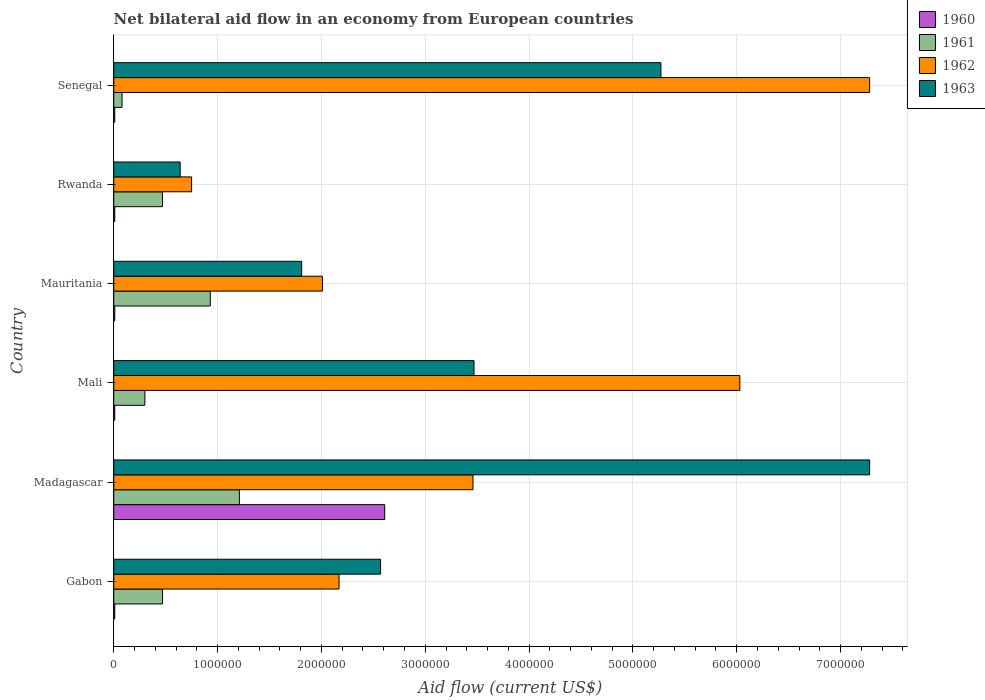What is the label of the 2nd group of bars from the top?
Your answer should be very brief. Rwanda. In how many cases, is the number of bars for a given country not equal to the number of legend labels?
Ensure brevity in your answer.  0. What is the net bilateral aid flow in 1961 in Mauritania?
Your answer should be compact. 9.30e+05. Across all countries, what is the maximum net bilateral aid flow in 1962?
Ensure brevity in your answer.  7.28e+06. In which country was the net bilateral aid flow in 1962 maximum?
Ensure brevity in your answer.  Senegal. In which country was the net bilateral aid flow in 1963 minimum?
Your answer should be very brief. Rwanda. What is the total net bilateral aid flow in 1960 in the graph?
Keep it short and to the point. 2.66e+06. What is the difference between the net bilateral aid flow in 1963 in Gabon and that in Senegal?
Ensure brevity in your answer.  -2.70e+06. What is the difference between the net bilateral aid flow in 1963 in Rwanda and the net bilateral aid flow in 1960 in Madagascar?
Keep it short and to the point. -1.97e+06. What is the average net bilateral aid flow in 1963 per country?
Give a very brief answer. 3.51e+06. What is the ratio of the net bilateral aid flow in 1960 in Mauritania to that in Rwanda?
Offer a terse response. 1. Is the net bilateral aid flow in 1960 in Mali less than that in Senegal?
Your response must be concise. No. What is the difference between the highest and the lowest net bilateral aid flow in 1962?
Give a very brief answer. 6.53e+06. In how many countries, is the net bilateral aid flow in 1961 greater than the average net bilateral aid flow in 1961 taken over all countries?
Offer a terse response. 2. What does the 4th bar from the top in Mali represents?
Offer a very short reply. 1960. Is it the case that in every country, the sum of the net bilateral aid flow in 1962 and net bilateral aid flow in 1960 is greater than the net bilateral aid flow in 1963?
Your answer should be compact. No. How many bars are there?
Provide a succinct answer. 24. What is the difference between two consecutive major ticks on the X-axis?
Your response must be concise. 1.00e+06. Are the values on the major ticks of X-axis written in scientific E-notation?
Make the answer very short. No. How are the legend labels stacked?
Your response must be concise. Vertical. What is the title of the graph?
Provide a short and direct response. Net bilateral aid flow in an economy from European countries. Does "1998" appear as one of the legend labels in the graph?
Your answer should be very brief. No. What is the label or title of the X-axis?
Make the answer very short. Aid flow (current US$). What is the label or title of the Y-axis?
Offer a terse response. Country. What is the Aid flow (current US$) in 1961 in Gabon?
Provide a succinct answer. 4.70e+05. What is the Aid flow (current US$) of 1962 in Gabon?
Keep it short and to the point. 2.17e+06. What is the Aid flow (current US$) in 1963 in Gabon?
Your answer should be very brief. 2.57e+06. What is the Aid flow (current US$) in 1960 in Madagascar?
Your answer should be very brief. 2.61e+06. What is the Aid flow (current US$) in 1961 in Madagascar?
Your answer should be compact. 1.21e+06. What is the Aid flow (current US$) in 1962 in Madagascar?
Your answer should be very brief. 3.46e+06. What is the Aid flow (current US$) in 1963 in Madagascar?
Provide a short and direct response. 7.28e+06. What is the Aid flow (current US$) in 1962 in Mali?
Ensure brevity in your answer.  6.03e+06. What is the Aid flow (current US$) in 1963 in Mali?
Offer a very short reply. 3.47e+06. What is the Aid flow (current US$) in 1961 in Mauritania?
Give a very brief answer. 9.30e+05. What is the Aid flow (current US$) of 1962 in Mauritania?
Make the answer very short. 2.01e+06. What is the Aid flow (current US$) in 1963 in Mauritania?
Give a very brief answer. 1.81e+06. What is the Aid flow (current US$) of 1961 in Rwanda?
Your answer should be compact. 4.70e+05. What is the Aid flow (current US$) in 1962 in Rwanda?
Your answer should be compact. 7.50e+05. What is the Aid flow (current US$) of 1963 in Rwanda?
Make the answer very short. 6.40e+05. What is the Aid flow (current US$) of 1961 in Senegal?
Offer a terse response. 8.00e+04. What is the Aid flow (current US$) in 1962 in Senegal?
Keep it short and to the point. 7.28e+06. What is the Aid flow (current US$) of 1963 in Senegal?
Make the answer very short. 5.27e+06. Across all countries, what is the maximum Aid flow (current US$) in 1960?
Your answer should be very brief. 2.61e+06. Across all countries, what is the maximum Aid flow (current US$) of 1961?
Give a very brief answer. 1.21e+06. Across all countries, what is the maximum Aid flow (current US$) in 1962?
Your response must be concise. 7.28e+06. Across all countries, what is the maximum Aid flow (current US$) of 1963?
Provide a succinct answer. 7.28e+06. Across all countries, what is the minimum Aid flow (current US$) in 1960?
Keep it short and to the point. 10000. Across all countries, what is the minimum Aid flow (current US$) in 1962?
Offer a terse response. 7.50e+05. Across all countries, what is the minimum Aid flow (current US$) of 1963?
Provide a succinct answer. 6.40e+05. What is the total Aid flow (current US$) of 1960 in the graph?
Provide a short and direct response. 2.66e+06. What is the total Aid flow (current US$) in 1961 in the graph?
Provide a short and direct response. 3.46e+06. What is the total Aid flow (current US$) in 1962 in the graph?
Keep it short and to the point. 2.17e+07. What is the total Aid flow (current US$) of 1963 in the graph?
Your answer should be compact. 2.10e+07. What is the difference between the Aid flow (current US$) in 1960 in Gabon and that in Madagascar?
Ensure brevity in your answer.  -2.60e+06. What is the difference between the Aid flow (current US$) in 1961 in Gabon and that in Madagascar?
Give a very brief answer. -7.40e+05. What is the difference between the Aid flow (current US$) in 1962 in Gabon and that in Madagascar?
Keep it short and to the point. -1.29e+06. What is the difference between the Aid flow (current US$) in 1963 in Gabon and that in Madagascar?
Provide a succinct answer. -4.71e+06. What is the difference between the Aid flow (current US$) of 1961 in Gabon and that in Mali?
Provide a short and direct response. 1.70e+05. What is the difference between the Aid flow (current US$) of 1962 in Gabon and that in Mali?
Offer a very short reply. -3.86e+06. What is the difference between the Aid flow (current US$) in 1963 in Gabon and that in Mali?
Offer a very short reply. -9.00e+05. What is the difference between the Aid flow (current US$) of 1960 in Gabon and that in Mauritania?
Your answer should be very brief. 0. What is the difference between the Aid flow (current US$) of 1961 in Gabon and that in Mauritania?
Your response must be concise. -4.60e+05. What is the difference between the Aid flow (current US$) in 1963 in Gabon and that in Mauritania?
Provide a short and direct response. 7.60e+05. What is the difference between the Aid flow (current US$) in 1960 in Gabon and that in Rwanda?
Offer a terse response. 0. What is the difference between the Aid flow (current US$) in 1962 in Gabon and that in Rwanda?
Ensure brevity in your answer.  1.42e+06. What is the difference between the Aid flow (current US$) in 1963 in Gabon and that in Rwanda?
Keep it short and to the point. 1.93e+06. What is the difference between the Aid flow (current US$) of 1960 in Gabon and that in Senegal?
Ensure brevity in your answer.  0. What is the difference between the Aid flow (current US$) of 1962 in Gabon and that in Senegal?
Keep it short and to the point. -5.11e+06. What is the difference between the Aid flow (current US$) of 1963 in Gabon and that in Senegal?
Give a very brief answer. -2.70e+06. What is the difference between the Aid flow (current US$) in 1960 in Madagascar and that in Mali?
Offer a very short reply. 2.60e+06. What is the difference between the Aid flow (current US$) in 1961 in Madagascar and that in Mali?
Provide a short and direct response. 9.10e+05. What is the difference between the Aid flow (current US$) in 1962 in Madagascar and that in Mali?
Provide a short and direct response. -2.57e+06. What is the difference between the Aid flow (current US$) of 1963 in Madagascar and that in Mali?
Your answer should be compact. 3.81e+06. What is the difference between the Aid flow (current US$) of 1960 in Madagascar and that in Mauritania?
Your response must be concise. 2.60e+06. What is the difference between the Aid flow (current US$) in 1961 in Madagascar and that in Mauritania?
Offer a terse response. 2.80e+05. What is the difference between the Aid flow (current US$) of 1962 in Madagascar and that in Mauritania?
Provide a succinct answer. 1.45e+06. What is the difference between the Aid flow (current US$) of 1963 in Madagascar and that in Mauritania?
Provide a short and direct response. 5.47e+06. What is the difference between the Aid flow (current US$) in 1960 in Madagascar and that in Rwanda?
Give a very brief answer. 2.60e+06. What is the difference between the Aid flow (current US$) in 1961 in Madagascar and that in Rwanda?
Provide a succinct answer. 7.40e+05. What is the difference between the Aid flow (current US$) in 1962 in Madagascar and that in Rwanda?
Provide a succinct answer. 2.71e+06. What is the difference between the Aid flow (current US$) in 1963 in Madagascar and that in Rwanda?
Offer a terse response. 6.64e+06. What is the difference between the Aid flow (current US$) in 1960 in Madagascar and that in Senegal?
Your response must be concise. 2.60e+06. What is the difference between the Aid flow (current US$) of 1961 in Madagascar and that in Senegal?
Offer a terse response. 1.13e+06. What is the difference between the Aid flow (current US$) in 1962 in Madagascar and that in Senegal?
Your answer should be compact. -3.82e+06. What is the difference between the Aid flow (current US$) of 1963 in Madagascar and that in Senegal?
Your response must be concise. 2.01e+06. What is the difference between the Aid flow (current US$) in 1960 in Mali and that in Mauritania?
Ensure brevity in your answer.  0. What is the difference between the Aid flow (current US$) of 1961 in Mali and that in Mauritania?
Offer a terse response. -6.30e+05. What is the difference between the Aid flow (current US$) of 1962 in Mali and that in Mauritania?
Provide a succinct answer. 4.02e+06. What is the difference between the Aid flow (current US$) in 1963 in Mali and that in Mauritania?
Provide a succinct answer. 1.66e+06. What is the difference between the Aid flow (current US$) in 1960 in Mali and that in Rwanda?
Make the answer very short. 0. What is the difference between the Aid flow (current US$) of 1962 in Mali and that in Rwanda?
Your answer should be compact. 5.28e+06. What is the difference between the Aid flow (current US$) in 1963 in Mali and that in Rwanda?
Your answer should be compact. 2.83e+06. What is the difference between the Aid flow (current US$) of 1960 in Mali and that in Senegal?
Your answer should be very brief. 0. What is the difference between the Aid flow (current US$) in 1962 in Mali and that in Senegal?
Offer a terse response. -1.25e+06. What is the difference between the Aid flow (current US$) in 1963 in Mali and that in Senegal?
Your response must be concise. -1.80e+06. What is the difference between the Aid flow (current US$) in 1962 in Mauritania and that in Rwanda?
Give a very brief answer. 1.26e+06. What is the difference between the Aid flow (current US$) in 1963 in Mauritania and that in Rwanda?
Ensure brevity in your answer.  1.17e+06. What is the difference between the Aid flow (current US$) in 1961 in Mauritania and that in Senegal?
Ensure brevity in your answer.  8.50e+05. What is the difference between the Aid flow (current US$) in 1962 in Mauritania and that in Senegal?
Your answer should be compact. -5.27e+06. What is the difference between the Aid flow (current US$) of 1963 in Mauritania and that in Senegal?
Provide a short and direct response. -3.46e+06. What is the difference between the Aid flow (current US$) of 1960 in Rwanda and that in Senegal?
Your response must be concise. 0. What is the difference between the Aid flow (current US$) in 1962 in Rwanda and that in Senegal?
Offer a terse response. -6.53e+06. What is the difference between the Aid flow (current US$) in 1963 in Rwanda and that in Senegal?
Provide a succinct answer. -4.63e+06. What is the difference between the Aid flow (current US$) in 1960 in Gabon and the Aid flow (current US$) in 1961 in Madagascar?
Offer a terse response. -1.20e+06. What is the difference between the Aid flow (current US$) in 1960 in Gabon and the Aid flow (current US$) in 1962 in Madagascar?
Provide a succinct answer. -3.45e+06. What is the difference between the Aid flow (current US$) of 1960 in Gabon and the Aid flow (current US$) of 1963 in Madagascar?
Provide a succinct answer. -7.27e+06. What is the difference between the Aid flow (current US$) of 1961 in Gabon and the Aid flow (current US$) of 1962 in Madagascar?
Keep it short and to the point. -2.99e+06. What is the difference between the Aid flow (current US$) in 1961 in Gabon and the Aid flow (current US$) in 1963 in Madagascar?
Ensure brevity in your answer.  -6.81e+06. What is the difference between the Aid flow (current US$) in 1962 in Gabon and the Aid flow (current US$) in 1963 in Madagascar?
Keep it short and to the point. -5.11e+06. What is the difference between the Aid flow (current US$) of 1960 in Gabon and the Aid flow (current US$) of 1962 in Mali?
Provide a short and direct response. -6.02e+06. What is the difference between the Aid flow (current US$) of 1960 in Gabon and the Aid flow (current US$) of 1963 in Mali?
Ensure brevity in your answer.  -3.46e+06. What is the difference between the Aid flow (current US$) of 1961 in Gabon and the Aid flow (current US$) of 1962 in Mali?
Your response must be concise. -5.56e+06. What is the difference between the Aid flow (current US$) of 1962 in Gabon and the Aid flow (current US$) of 1963 in Mali?
Your response must be concise. -1.30e+06. What is the difference between the Aid flow (current US$) in 1960 in Gabon and the Aid flow (current US$) in 1961 in Mauritania?
Provide a succinct answer. -9.20e+05. What is the difference between the Aid flow (current US$) in 1960 in Gabon and the Aid flow (current US$) in 1963 in Mauritania?
Your answer should be compact. -1.80e+06. What is the difference between the Aid flow (current US$) of 1961 in Gabon and the Aid flow (current US$) of 1962 in Mauritania?
Your answer should be very brief. -1.54e+06. What is the difference between the Aid flow (current US$) in 1961 in Gabon and the Aid flow (current US$) in 1963 in Mauritania?
Your answer should be very brief. -1.34e+06. What is the difference between the Aid flow (current US$) in 1960 in Gabon and the Aid flow (current US$) in 1961 in Rwanda?
Provide a short and direct response. -4.60e+05. What is the difference between the Aid flow (current US$) of 1960 in Gabon and the Aid flow (current US$) of 1962 in Rwanda?
Offer a terse response. -7.40e+05. What is the difference between the Aid flow (current US$) in 1960 in Gabon and the Aid flow (current US$) in 1963 in Rwanda?
Give a very brief answer. -6.30e+05. What is the difference between the Aid flow (current US$) in 1961 in Gabon and the Aid flow (current US$) in 1962 in Rwanda?
Your answer should be compact. -2.80e+05. What is the difference between the Aid flow (current US$) in 1962 in Gabon and the Aid flow (current US$) in 1963 in Rwanda?
Your answer should be very brief. 1.53e+06. What is the difference between the Aid flow (current US$) of 1960 in Gabon and the Aid flow (current US$) of 1962 in Senegal?
Make the answer very short. -7.27e+06. What is the difference between the Aid flow (current US$) in 1960 in Gabon and the Aid flow (current US$) in 1963 in Senegal?
Provide a short and direct response. -5.26e+06. What is the difference between the Aid flow (current US$) of 1961 in Gabon and the Aid flow (current US$) of 1962 in Senegal?
Provide a succinct answer. -6.81e+06. What is the difference between the Aid flow (current US$) of 1961 in Gabon and the Aid flow (current US$) of 1963 in Senegal?
Keep it short and to the point. -4.80e+06. What is the difference between the Aid flow (current US$) of 1962 in Gabon and the Aid flow (current US$) of 1963 in Senegal?
Provide a short and direct response. -3.10e+06. What is the difference between the Aid flow (current US$) in 1960 in Madagascar and the Aid flow (current US$) in 1961 in Mali?
Your answer should be very brief. 2.31e+06. What is the difference between the Aid flow (current US$) of 1960 in Madagascar and the Aid flow (current US$) of 1962 in Mali?
Keep it short and to the point. -3.42e+06. What is the difference between the Aid flow (current US$) in 1960 in Madagascar and the Aid flow (current US$) in 1963 in Mali?
Ensure brevity in your answer.  -8.60e+05. What is the difference between the Aid flow (current US$) in 1961 in Madagascar and the Aid flow (current US$) in 1962 in Mali?
Make the answer very short. -4.82e+06. What is the difference between the Aid flow (current US$) of 1961 in Madagascar and the Aid flow (current US$) of 1963 in Mali?
Provide a succinct answer. -2.26e+06. What is the difference between the Aid flow (current US$) in 1962 in Madagascar and the Aid flow (current US$) in 1963 in Mali?
Provide a short and direct response. -10000. What is the difference between the Aid flow (current US$) of 1960 in Madagascar and the Aid flow (current US$) of 1961 in Mauritania?
Offer a very short reply. 1.68e+06. What is the difference between the Aid flow (current US$) in 1961 in Madagascar and the Aid flow (current US$) in 1962 in Mauritania?
Give a very brief answer. -8.00e+05. What is the difference between the Aid flow (current US$) in 1961 in Madagascar and the Aid flow (current US$) in 1963 in Mauritania?
Your response must be concise. -6.00e+05. What is the difference between the Aid flow (current US$) of 1962 in Madagascar and the Aid flow (current US$) of 1963 in Mauritania?
Provide a short and direct response. 1.65e+06. What is the difference between the Aid flow (current US$) of 1960 in Madagascar and the Aid flow (current US$) of 1961 in Rwanda?
Provide a short and direct response. 2.14e+06. What is the difference between the Aid flow (current US$) of 1960 in Madagascar and the Aid flow (current US$) of 1962 in Rwanda?
Make the answer very short. 1.86e+06. What is the difference between the Aid flow (current US$) of 1960 in Madagascar and the Aid flow (current US$) of 1963 in Rwanda?
Your answer should be very brief. 1.97e+06. What is the difference between the Aid flow (current US$) in 1961 in Madagascar and the Aid flow (current US$) in 1963 in Rwanda?
Keep it short and to the point. 5.70e+05. What is the difference between the Aid flow (current US$) of 1962 in Madagascar and the Aid flow (current US$) of 1963 in Rwanda?
Keep it short and to the point. 2.82e+06. What is the difference between the Aid flow (current US$) in 1960 in Madagascar and the Aid flow (current US$) in 1961 in Senegal?
Offer a terse response. 2.53e+06. What is the difference between the Aid flow (current US$) in 1960 in Madagascar and the Aid flow (current US$) in 1962 in Senegal?
Your answer should be very brief. -4.67e+06. What is the difference between the Aid flow (current US$) of 1960 in Madagascar and the Aid flow (current US$) of 1963 in Senegal?
Provide a succinct answer. -2.66e+06. What is the difference between the Aid flow (current US$) in 1961 in Madagascar and the Aid flow (current US$) in 1962 in Senegal?
Make the answer very short. -6.07e+06. What is the difference between the Aid flow (current US$) in 1961 in Madagascar and the Aid flow (current US$) in 1963 in Senegal?
Keep it short and to the point. -4.06e+06. What is the difference between the Aid flow (current US$) in 1962 in Madagascar and the Aid flow (current US$) in 1963 in Senegal?
Your answer should be compact. -1.81e+06. What is the difference between the Aid flow (current US$) in 1960 in Mali and the Aid flow (current US$) in 1961 in Mauritania?
Your response must be concise. -9.20e+05. What is the difference between the Aid flow (current US$) of 1960 in Mali and the Aid flow (current US$) of 1963 in Mauritania?
Offer a very short reply. -1.80e+06. What is the difference between the Aid flow (current US$) in 1961 in Mali and the Aid flow (current US$) in 1962 in Mauritania?
Provide a succinct answer. -1.71e+06. What is the difference between the Aid flow (current US$) of 1961 in Mali and the Aid flow (current US$) of 1963 in Mauritania?
Keep it short and to the point. -1.51e+06. What is the difference between the Aid flow (current US$) in 1962 in Mali and the Aid flow (current US$) in 1963 in Mauritania?
Give a very brief answer. 4.22e+06. What is the difference between the Aid flow (current US$) in 1960 in Mali and the Aid flow (current US$) in 1961 in Rwanda?
Provide a short and direct response. -4.60e+05. What is the difference between the Aid flow (current US$) of 1960 in Mali and the Aid flow (current US$) of 1962 in Rwanda?
Keep it short and to the point. -7.40e+05. What is the difference between the Aid flow (current US$) in 1960 in Mali and the Aid flow (current US$) in 1963 in Rwanda?
Ensure brevity in your answer.  -6.30e+05. What is the difference between the Aid flow (current US$) in 1961 in Mali and the Aid flow (current US$) in 1962 in Rwanda?
Make the answer very short. -4.50e+05. What is the difference between the Aid flow (current US$) of 1962 in Mali and the Aid flow (current US$) of 1963 in Rwanda?
Ensure brevity in your answer.  5.39e+06. What is the difference between the Aid flow (current US$) in 1960 in Mali and the Aid flow (current US$) in 1961 in Senegal?
Your response must be concise. -7.00e+04. What is the difference between the Aid flow (current US$) of 1960 in Mali and the Aid flow (current US$) of 1962 in Senegal?
Provide a short and direct response. -7.27e+06. What is the difference between the Aid flow (current US$) of 1960 in Mali and the Aid flow (current US$) of 1963 in Senegal?
Make the answer very short. -5.26e+06. What is the difference between the Aid flow (current US$) of 1961 in Mali and the Aid flow (current US$) of 1962 in Senegal?
Your answer should be very brief. -6.98e+06. What is the difference between the Aid flow (current US$) of 1961 in Mali and the Aid flow (current US$) of 1963 in Senegal?
Your response must be concise. -4.97e+06. What is the difference between the Aid flow (current US$) of 1962 in Mali and the Aid flow (current US$) of 1963 in Senegal?
Offer a very short reply. 7.60e+05. What is the difference between the Aid flow (current US$) in 1960 in Mauritania and the Aid flow (current US$) in 1961 in Rwanda?
Your answer should be compact. -4.60e+05. What is the difference between the Aid flow (current US$) in 1960 in Mauritania and the Aid flow (current US$) in 1962 in Rwanda?
Provide a short and direct response. -7.40e+05. What is the difference between the Aid flow (current US$) of 1960 in Mauritania and the Aid flow (current US$) of 1963 in Rwanda?
Keep it short and to the point. -6.30e+05. What is the difference between the Aid flow (current US$) of 1961 in Mauritania and the Aid flow (current US$) of 1962 in Rwanda?
Keep it short and to the point. 1.80e+05. What is the difference between the Aid flow (current US$) of 1962 in Mauritania and the Aid flow (current US$) of 1963 in Rwanda?
Give a very brief answer. 1.37e+06. What is the difference between the Aid flow (current US$) in 1960 in Mauritania and the Aid flow (current US$) in 1962 in Senegal?
Provide a succinct answer. -7.27e+06. What is the difference between the Aid flow (current US$) of 1960 in Mauritania and the Aid flow (current US$) of 1963 in Senegal?
Offer a terse response. -5.26e+06. What is the difference between the Aid flow (current US$) of 1961 in Mauritania and the Aid flow (current US$) of 1962 in Senegal?
Your answer should be compact. -6.35e+06. What is the difference between the Aid flow (current US$) of 1961 in Mauritania and the Aid flow (current US$) of 1963 in Senegal?
Give a very brief answer. -4.34e+06. What is the difference between the Aid flow (current US$) of 1962 in Mauritania and the Aid flow (current US$) of 1963 in Senegal?
Make the answer very short. -3.26e+06. What is the difference between the Aid flow (current US$) in 1960 in Rwanda and the Aid flow (current US$) in 1962 in Senegal?
Offer a terse response. -7.27e+06. What is the difference between the Aid flow (current US$) of 1960 in Rwanda and the Aid flow (current US$) of 1963 in Senegal?
Keep it short and to the point. -5.26e+06. What is the difference between the Aid flow (current US$) of 1961 in Rwanda and the Aid flow (current US$) of 1962 in Senegal?
Keep it short and to the point. -6.81e+06. What is the difference between the Aid flow (current US$) of 1961 in Rwanda and the Aid flow (current US$) of 1963 in Senegal?
Your answer should be very brief. -4.80e+06. What is the difference between the Aid flow (current US$) of 1962 in Rwanda and the Aid flow (current US$) of 1963 in Senegal?
Ensure brevity in your answer.  -4.52e+06. What is the average Aid flow (current US$) in 1960 per country?
Your answer should be compact. 4.43e+05. What is the average Aid flow (current US$) of 1961 per country?
Offer a terse response. 5.77e+05. What is the average Aid flow (current US$) in 1962 per country?
Make the answer very short. 3.62e+06. What is the average Aid flow (current US$) in 1963 per country?
Offer a very short reply. 3.51e+06. What is the difference between the Aid flow (current US$) in 1960 and Aid flow (current US$) in 1961 in Gabon?
Provide a short and direct response. -4.60e+05. What is the difference between the Aid flow (current US$) of 1960 and Aid flow (current US$) of 1962 in Gabon?
Offer a terse response. -2.16e+06. What is the difference between the Aid flow (current US$) of 1960 and Aid flow (current US$) of 1963 in Gabon?
Your response must be concise. -2.56e+06. What is the difference between the Aid flow (current US$) of 1961 and Aid flow (current US$) of 1962 in Gabon?
Ensure brevity in your answer.  -1.70e+06. What is the difference between the Aid flow (current US$) of 1961 and Aid flow (current US$) of 1963 in Gabon?
Your answer should be very brief. -2.10e+06. What is the difference between the Aid flow (current US$) of 1962 and Aid flow (current US$) of 1963 in Gabon?
Provide a succinct answer. -4.00e+05. What is the difference between the Aid flow (current US$) in 1960 and Aid flow (current US$) in 1961 in Madagascar?
Provide a succinct answer. 1.40e+06. What is the difference between the Aid flow (current US$) in 1960 and Aid flow (current US$) in 1962 in Madagascar?
Keep it short and to the point. -8.50e+05. What is the difference between the Aid flow (current US$) in 1960 and Aid flow (current US$) in 1963 in Madagascar?
Ensure brevity in your answer.  -4.67e+06. What is the difference between the Aid flow (current US$) in 1961 and Aid flow (current US$) in 1962 in Madagascar?
Your response must be concise. -2.25e+06. What is the difference between the Aid flow (current US$) in 1961 and Aid flow (current US$) in 1963 in Madagascar?
Keep it short and to the point. -6.07e+06. What is the difference between the Aid flow (current US$) in 1962 and Aid flow (current US$) in 1963 in Madagascar?
Your answer should be very brief. -3.82e+06. What is the difference between the Aid flow (current US$) of 1960 and Aid flow (current US$) of 1962 in Mali?
Your answer should be compact. -6.02e+06. What is the difference between the Aid flow (current US$) of 1960 and Aid flow (current US$) of 1963 in Mali?
Ensure brevity in your answer.  -3.46e+06. What is the difference between the Aid flow (current US$) of 1961 and Aid flow (current US$) of 1962 in Mali?
Provide a succinct answer. -5.73e+06. What is the difference between the Aid flow (current US$) of 1961 and Aid flow (current US$) of 1963 in Mali?
Your response must be concise. -3.17e+06. What is the difference between the Aid flow (current US$) in 1962 and Aid flow (current US$) in 1963 in Mali?
Give a very brief answer. 2.56e+06. What is the difference between the Aid flow (current US$) in 1960 and Aid flow (current US$) in 1961 in Mauritania?
Keep it short and to the point. -9.20e+05. What is the difference between the Aid flow (current US$) of 1960 and Aid flow (current US$) of 1962 in Mauritania?
Offer a terse response. -2.00e+06. What is the difference between the Aid flow (current US$) in 1960 and Aid flow (current US$) in 1963 in Mauritania?
Your response must be concise. -1.80e+06. What is the difference between the Aid flow (current US$) in 1961 and Aid flow (current US$) in 1962 in Mauritania?
Your answer should be compact. -1.08e+06. What is the difference between the Aid flow (current US$) of 1961 and Aid flow (current US$) of 1963 in Mauritania?
Your answer should be compact. -8.80e+05. What is the difference between the Aid flow (current US$) of 1960 and Aid flow (current US$) of 1961 in Rwanda?
Keep it short and to the point. -4.60e+05. What is the difference between the Aid flow (current US$) in 1960 and Aid flow (current US$) in 1962 in Rwanda?
Offer a terse response. -7.40e+05. What is the difference between the Aid flow (current US$) in 1960 and Aid flow (current US$) in 1963 in Rwanda?
Provide a short and direct response. -6.30e+05. What is the difference between the Aid flow (current US$) of 1961 and Aid flow (current US$) of 1962 in Rwanda?
Your answer should be very brief. -2.80e+05. What is the difference between the Aid flow (current US$) in 1961 and Aid flow (current US$) in 1963 in Rwanda?
Your response must be concise. -1.70e+05. What is the difference between the Aid flow (current US$) in 1962 and Aid flow (current US$) in 1963 in Rwanda?
Offer a very short reply. 1.10e+05. What is the difference between the Aid flow (current US$) in 1960 and Aid flow (current US$) in 1961 in Senegal?
Give a very brief answer. -7.00e+04. What is the difference between the Aid flow (current US$) of 1960 and Aid flow (current US$) of 1962 in Senegal?
Ensure brevity in your answer.  -7.27e+06. What is the difference between the Aid flow (current US$) of 1960 and Aid flow (current US$) of 1963 in Senegal?
Provide a succinct answer. -5.26e+06. What is the difference between the Aid flow (current US$) of 1961 and Aid flow (current US$) of 1962 in Senegal?
Give a very brief answer. -7.20e+06. What is the difference between the Aid flow (current US$) in 1961 and Aid flow (current US$) in 1963 in Senegal?
Make the answer very short. -5.19e+06. What is the difference between the Aid flow (current US$) in 1962 and Aid flow (current US$) in 1963 in Senegal?
Ensure brevity in your answer.  2.01e+06. What is the ratio of the Aid flow (current US$) in 1960 in Gabon to that in Madagascar?
Your answer should be very brief. 0. What is the ratio of the Aid flow (current US$) of 1961 in Gabon to that in Madagascar?
Keep it short and to the point. 0.39. What is the ratio of the Aid flow (current US$) of 1962 in Gabon to that in Madagascar?
Make the answer very short. 0.63. What is the ratio of the Aid flow (current US$) in 1963 in Gabon to that in Madagascar?
Your answer should be very brief. 0.35. What is the ratio of the Aid flow (current US$) in 1961 in Gabon to that in Mali?
Make the answer very short. 1.57. What is the ratio of the Aid flow (current US$) of 1962 in Gabon to that in Mali?
Give a very brief answer. 0.36. What is the ratio of the Aid flow (current US$) in 1963 in Gabon to that in Mali?
Ensure brevity in your answer.  0.74. What is the ratio of the Aid flow (current US$) in 1960 in Gabon to that in Mauritania?
Your answer should be very brief. 1. What is the ratio of the Aid flow (current US$) in 1961 in Gabon to that in Mauritania?
Provide a short and direct response. 0.51. What is the ratio of the Aid flow (current US$) of 1962 in Gabon to that in Mauritania?
Make the answer very short. 1.08. What is the ratio of the Aid flow (current US$) in 1963 in Gabon to that in Mauritania?
Provide a succinct answer. 1.42. What is the ratio of the Aid flow (current US$) in 1960 in Gabon to that in Rwanda?
Provide a succinct answer. 1. What is the ratio of the Aid flow (current US$) of 1962 in Gabon to that in Rwanda?
Keep it short and to the point. 2.89. What is the ratio of the Aid flow (current US$) of 1963 in Gabon to that in Rwanda?
Keep it short and to the point. 4.02. What is the ratio of the Aid flow (current US$) in 1960 in Gabon to that in Senegal?
Make the answer very short. 1. What is the ratio of the Aid flow (current US$) in 1961 in Gabon to that in Senegal?
Give a very brief answer. 5.88. What is the ratio of the Aid flow (current US$) of 1962 in Gabon to that in Senegal?
Your answer should be compact. 0.3. What is the ratio of the Aid flow (current US$) of 1963 in Gabon to that in Senegal?
Offer a terse response. 0.49. What is the ratio of the Aid flow (current US$) of 1960 in Madagascar to that in Mali?
Provide a succinct answer. 261. What is the ratio of the Aid flow (current US$) in 1961 in Madagascar to that in Mali?
Offer a terse response. 4.03. What is the ratio of the Aid flow (current US$) of 1962 in Madagascar to that in Mali?
Provide a succinct answer. 0.57. What is the ratio of the Aid flow (current US$) in 1963 in Madagascar to that in Mali?
Offer a very short reply. 2.1. What is the ratio of the Aid flow (current US$) of 1960 in Madagascar to that in Mauritania?
Give a very brief answer. 261. What is the ratio of the Aid flow (current US$) of 1961 in Madagascar to that in Mauritania?
Make the answer very short. 1.3. What is the ratio of the Aid flow (current US$) in 1962 in Madagascar to that in Mauritania?
Make the answer very short. 1.72. What is the ratio of the Aid flow (current US$) of 1963 in Madagascar to that in Mauritania?
Offer a terse response. 4.02. What is the ratio of the Aid flow (current US$) of 1960 in Madagascar to that in Rwanda?
Offer a terse response. 261. What is the ratio of the Aid flow (current US$) of 1961 in Madagascar to that in Rwanda?
Your response must be concise. 2.57. What is the ratio of the Aid flow (current US$) in 1962 in Madagascar to that in Rwanda?
Give a very brief answer. 4.61. What is the ratio of the Aid flow (current US$) in 1963 in Madagascar to that in Rwanda?
Offer a terse response. 11.38. What is the ratio of the Aid flow (current US$) in 1960 in Madagascar to that in Senegal?
Offer a very short reply. 261. What is the ratio of the Aid flow (current US$) of 1961 in Madagascar to that in Senegal?
Offer a very short reply. 15.12. What is the ratio of the Aid flow (current US$) in 1962 in Madagascar to that in Senegal?
Provide a short and direct response. 0.48. What is the ratio of the Aid flow (current US$) in 1963 in Madagascar to that in Senegal?
Provide a succinct answer. 1.38. What is the ratio of the Aid flow (current US$) of 1961 in Mali to that in Mauritania?
Make the answer very short. 0.32. What is the ratio of the Aid flow (current US$) of 1962 in Mali to that in Mauritania?
Keep it short and to the point. 3. What is the ratio of the Aid flow (current US$) in 1963 in Mali to that in Mauritania?
Provide a short and direct response. 1.92. What is the ratio of the Aid flow (current US$) in 1960 in Mali to that in Rwanda?
Provide a succinct answer. 1. What is the ratio of the Aid flow (current US$) in 1961 in Mali to that in Rwanda?
Give a very brief answer. 0.64. What is the ratio of the Aid flow (current US$) of 1962 in Mali to that in Rwanda?
Provide a short and direct response. 8.04. What is the ratio of the Aid flow (current US$) in 1963 in Mali to that in Rwanda?
Provide a succinct answer. 5.42. What is the ratio of the Aid flow (current US$) in 1960 in Mali to that in Senegal?
Offer a very short reply. 1. What is the ratio of the Aid flow (current US$) of 1961 in Mali to that in Senegal?
Provide a succinct answer. 3.75. What is the ratio of the Aid flow (current US$) in 1962 in Mali to that in Senegal?
Keep it short and to the point. 0.83. What is the ratio of the Aid flow (current US$) in 1963 in Mali to that in Senegal?
Ensure brevity in your answer.  0.66. What is the ratio of the Aid flow (current US$) of 1961 in Mauritania to that in Rwanda?
Offer a very short reply. 1.98. What is the ratio of the Aid flow (current US$) of 1962 in Mauritania to that in Rwanda?
Your response must be concise. 2.68. What is the ratio of the Aid flow (current US$) in 1963 in Mauritania to that in Rwanda?
Your answer should be compact. 2.83. What is the ratio of the Aid flow (current US$) of 1960 in Mauritania to that in Senegal?
Give a very brief answer. 1. What is the ratio of the Aid flow (current US$) of 1961 in Mauritania to that in Senegal?
Your answer should be compact. 11.62. What is the ratio of the Aid flow (current US$) in 1962 in Mauritania to that in Senegal?
Your response must be concise. 0.28. What is the ratio of the Aid flow (current US$) of 1963 in Mauritania to that in Senegal?
Keep it short and to the point. 0.34. What is the ratio of the Aid flow (current US$) in 1960 in Rwanda to that in Senegal?
Your response must be concise. 1. What is the ratio of the Aid flow (current US$) of 1961 in Rwanda to that in Senegal?
Keep it short and to the point. 5.88. What is the ratio of the Aid flow (current US$) of 1962 in Rwanda to that in Senegal?
Your answer should be compact. 0.1. What is the ratio of the Aid flow (current US$) of 1963 in Rwanda to that in Senegal?
Offer a terse response. 0.12. What is the difference between the highest and the second highest Aid flow (current US$) in 1960?
Provide a succinct answer. 2.60e+06. What is the difference between the highest and the second highest Aid flow (current US$) in 1962?
Provide a succinct answer. 1.25e+06. What is the difference between the highest and the second highest Aid flow (current US$) of 1963?
Make the answer very short. 2.01e+06. What is the difference between the highest and the lowest Aid flow (current US$) of 1960?
Keep it short and to the point. 2.60e+06. What is the difference between the highest and the lowest Aid flow (current US$) of 1961?
Your answer should be very brief. 1.13e+06. What is the difference between the highest and the lowest Aid flow (current US$) in 1962?
Give a very brief answer. 6.53e+06. What is the difference between the highest and the lowest Aid flow (current US$) of 1963?
Offer a terse response. 6.64e+06. 